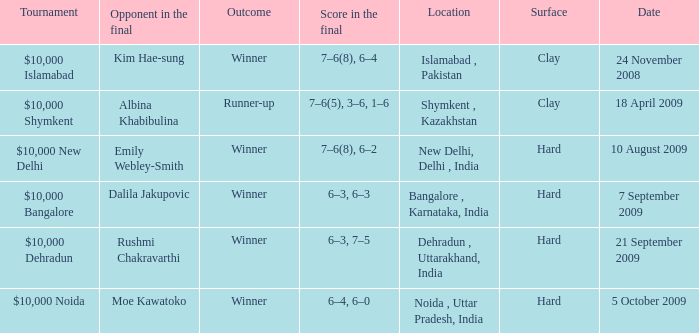What is the material of the surface in the dehradun , uttarakhand, india location Hard. 